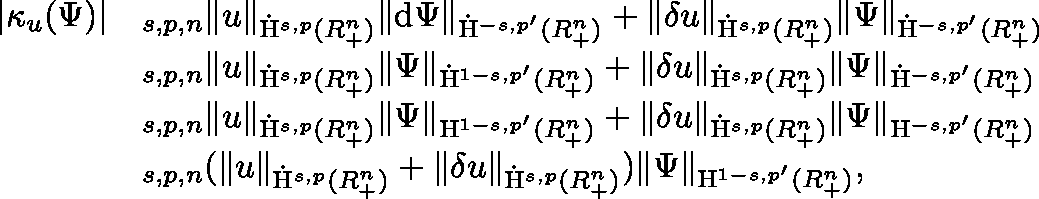Convert formula to latex. <formula><loc_0><loc_0><loc_500><loc_500>\begin{array} { r l } { | \kappa _ { u } ( \Psi ) | } & { \lesssim _ { s , p , n } \| u \| _ { \dot { H } ^ { s , p } ( \mathbb { R } _ { + } ^ { n } ) } \| d \Psi \| _ { \dot { H } ^ { - s , p ^ { \prime } } ( \mathbb { R } _ { + } ^ { n } ) } + \| \delta u \| _ { \dot { H } ^ { s , p } ( \mathbb { R } _ { + } ^ { n } ) } \| \Psi \| _ { \dot { H } ^ { - s , p ^ { \prime } } ( \mathbb { R } _ { + } ^ { n } ) } } \\ & { \lesssim _ { s , p , n } \| u \| _ { \dot { H } ^ { s , p } ( \mathbb { R } _ { + } ^ { n } ) } \| \Psi \| _ { \dot { H } ^ { 1 - s , p ^ { \prime } } ( \mathbb { R } _ { + } ^ { n } ) } + \| \delta u \| _ { \dot { H } ^ { s , p } ( \mathbb { R } _ { + } ^ { n } ) } \| \Psi \| _ { \dot { H } ^ { - s , p ^ { \prime } } ( \mathbb { R } _ { + } ^ { n } ) } } \\ & { \lesssim _ { s , p , n } \| u \| _ { \dot { H } ^ { s , p } ( \mathbb { R } _ { + } ^ { n } ) } \| \Psi \| _ { { H } ^ { 1 - s , p ^ { \prime } } ( \mathbb { R } _ { + } ^ { n } ) } + \| \delta u \| _ { \dot { H } ^ { s , p } ( \mathbb { R } _ { + } ^ { n } ) } \| \Psi \| _ { { H } ^ { - s , p ^ { \prime } } ( \mathbb { R } _ { + } ^ { n } ) } } \\ & { \lesssim _ { s , p , n } ( \| u \| _ { \dot { H } ^ { s , p } ( \mathbb { R } _ { + } ^ { n } ) } + \| \delta u \| _ { \dot { H } ^ { s , p } ( \mathbb { R } _ { + } ^ { n } ) } ) \| \Psi \| _ { { H } ^ { 1 - s , p ^ { \prime } } ( \mathbb { R } _ { + } ^ { n } ) } , } \end{array}</formula> 